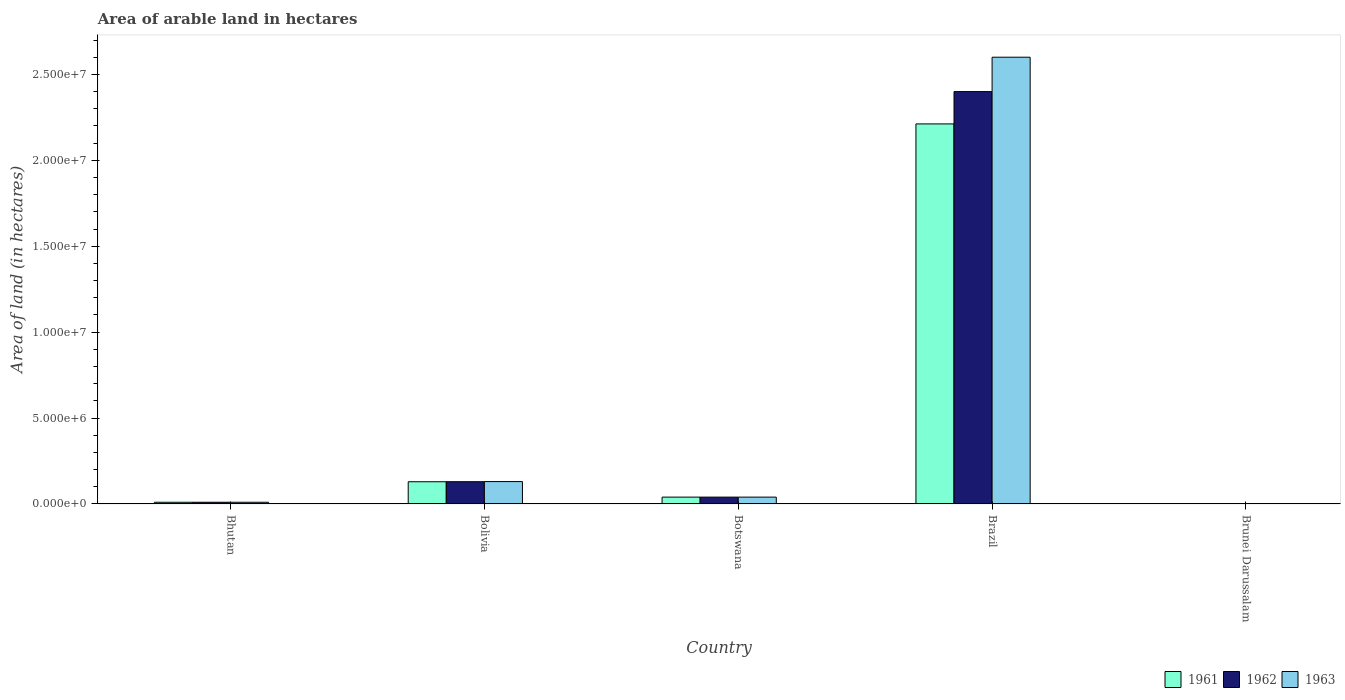How many groups of bars are there?
Your answer should be very brief. 5. Are the number of bars per tick equal to the number of legend labels?
Ensure brevity in your answer.  Yes. What is the label of the 3rd group of bars from the left?
Provide a succinct answer. Botswana. What is the total arable land in 1961 in Bolivia?
Keep it short and to the point. 1.29e+06. Across all countries, what is the maximum total arable land in 1962?
Ensure brevity in your answer.  2.40e+07. Across all countries, what is the minimum total arable land in 1963?
Provide a short and direct response. 4000. In which country was the total arable land in 1963 maximum?
Provide a succinct answer. Brazil. In which country was the total arable land in 1961 minimum?
Offer a terse response. Brunei Darussalam. What is the total total arable land in 1962 in the graph?
Provide a succinct answer. 2.58e+07. What is the difference between the total arable land in 1962 in Bolivia and that in Botswana?
Your response must be concise. 8.97e+05. What is the difference between the total arable land in 1962 in Bhutan and the total arable land in 1963 in Botswana?
Your answer should be very brief. -2.99e+05. What is the average total arable land in 1962 per country?
Offer a very short reply. 5.16e+06. What is the difference between the total arable land of/in 1961 and total arable land of/in 1963 in Bhutan?
Your answer should be compact. 0. In how many countries, is the total arable land in 1963 greater than 10000000 hectares?
Your response must be concise. 1. What is the difference between the highest and the second highest total arable land in 1963?
Your answer should be very brief. 2.56e+07. What is the difference between the highest and the lowest total arable land in 1962?
Offer a very short reply. 2.40e+07. In how many countries, is the total arable land in 1961 greater than the average total arable land in 1961 taken over all countries?
Keep it short and to the point. 1. What does the 3rd bar from the right in Bhutan represents?
Offer a terse response. 1961. Is it the case that in every country, the sum of the total arable land in 1961 and total arable land in 1963 is greater than the total arable land in 1962?
Ensure brevity in your answer.  Yes. How many bars are there?
Your answer should be very brief. 15. Are all the bars in the graph horizontal?
Provide a succinct answer. No. Are the values on the major ticks of Y-axis written in scientific E-notation?
Provide a short and direct response. Yes. Does the graph contain any zero values?
Keep it short and to the point. No. What is the title of the graph?
Ensure brevity in your answer.  Area of arable land in hectares. Does "1992" appear as one of the legend labels in the graph?
Your answer should be very brief. No. What is the label or title of the Y-axis?
Provide a succinct answer. Area of land (in hectares). What is the Area of land (in hectares) in 1961 in Bhutan?
Ensure brevity in your answer.  1.00e+05. What is the Area of land (in hectares) in 1962 in Bhutan?
Your answer should be very brief. 1.00e+05. What is the Area of land (in hectares) of 1963 in Bhutan?
Your response must be concise. 1.00e+05. What is the Area of land (in hectares) of 1961 in Bolivia?
Ensure brevity in your answer.  1.29e+06. What is the Area of land (in hectares) in 1962 in Bolivia?
Provide a succinct answer. 1.30e+06. What is the Area of land (in hectares) of 1963 in Bolivia?
Offer a very short reply. 1.30e+06. What is the Area of land (in hectares) in 1961 in Botswana?
Provide a short and direct response. 3.99e+05. What is the Area of land (in hectares) in 1962 in Botswana?
Make the answer very short. 3.99e+05. What is the Area of land (in hectares) of 1963 in Botswana?
Keep it short and to the point. 3.99e+05. What is the Area of land (in hectares) in 1961 in Brazil?
Your answer should be very brief. 2.21e+07. What is the Area of land (in hectares) in 1962 in Brazil?
Your response must be concise. 2.40e+07. What is the Area of land (in hectares) of 1963 in Brazil?
Your response must be concise. 2.60e+07. What is the Area of land (in hectares) in 1961 in Brunei Darussalam?
Your answer should be compact. 4000. What is the Area of land (in hectares) in 1962 in Brunei Darussalam?
Keep it short and to the point. 4000. What is the Area of land (in hectares) of 1963 in Brunei Darussalam?
Ensure brevity in your answer.  4000. Across all countries, what is the maximum Area of land (in hectares) in 1961?
Offer a terse response. 2.21e+07. Across all countries, what is the maximum Area of land (in hectares) in 1962?
Ensure brevity in your answer.  2.40e+07. Across all countries, what is the maximum Area of land (in hectares) in 1963?
Keep it short and to the point. 2.60e+07. Across all countries, what is the minimum Area of land (in hectares) in 1961?
Provide a short and direct response. 4000. Across all countries, what is the minimum Area of land (in hectares) of 1962?
Give a very brief answer. 4000. Across all countries, what is the minimum Area of land (in hectares) in 1963?
Ensure brevity in your answer.  4000. What is the total Area of land (in hectares) in 1961 in the graph?
Keep it short and to the point. 2.39e+07. What is the total Area of land (in hectares) in 1962 in the graph?
Your response must be concise. 2.58e+07. What is the total Area of land (in hectares) in 1963 in the graph?
Provide a short and direct response. 2.78e+07. What is the difference between the Area of land (in hectares) of 1961 in Bhutan and that in Bolivia?
Offer a very short reply. -1.19e+06. What is the difference between the Area of land (in hectares) in 1962 in Bhutan and that in Bolivia?
Your answer should be compact. -1.20e+06. What is the difference between the Area of land (in hectares) in 1963 in Bhutan and that in Bolivia?
Give a very brief answer. -1.20e+06. What is the difference between the Area of land (in hectares) in 1961 in Bhutan and that in Botswana?
Ensure brevity in your answer.  -2.99e+05. What is the difference between the Area of land (in hectares) of 1962 in Bhutan and that in Botswana?
Your response must be concise. -2.99e+05. What is the difference between the Area of land (in hectares) in 1963 in Bhutan and that in Botswana?
Provide a short and direct response. -2.99e+05. What is the difference between the Area of land (in hectares) in 1961 in Bhutan and that in Brazil?
Keep it short and to the point. -2.20e+07. What is the difference between the Area of land (in hectares) in 1962 in Bhutan and that in Brazil?
Make the answer very short. -2.39e+07. What is the difference between the Area of land (in hectares) in 1963 in Bhutan and that in Brazil?
Provide a short and direct response. -2.59e+07. What is the difference between the Area of land (in hectares) in 1961 in Bhutan and that in Brunei Darussalam?
Provide a succinct answer. 9.60e+04. What is the difference between the Area of land (in hectares) of 1962 in Bhutan and that in Brunei Darussalam?
Your answer should be compact. 9.60e+04. What is the difference between the Area of land (in hectares) of 1963 in Bhutan and that in Brunei Darussalam?
Offer a terse response. 9.60e+04. What is the difference between the Area of land (in hectares) in 1961 in Bolivia and that in Botswana?
Offer a terse response. 8.95e+05. What is the difference between the Area of land (in hectares) of 1962 in Bolivia and that in Botswana?
Provide a succinct answer. 8.97e+05. What is the difference between the Area of land (in hectares) of 1963 in Bolivia and that in Botswana?
Your answer should be compact. 9.05e+05. What is the difference between the Area of land (in hectares) in 1961 in Bolivia and that in Brazil?
Offer a terse response. -2.08e+07. What is the difference between the Area of land (in hectares) in 1962 in Bolivia and that in Brazil?
Ensure brevity in your answer.  -2.27e+07. What is the difference between the Area of land (in hectares) in 1963 in Bolivia and that in Brazil?
Your answer should be compact. -2.47e+07. What is the difference between the Area of land (in hectares) in 1961 in Bolivia and that in Brunei Darussalam?
Provide a succinct answer. 1.29e+06. What is the difference between the Area of land (in hectares) in 1962 in Bolivia and that in Brunei Darussalam?
Keep it short and to the point. 1.29e+06. What is the difference between the Area of land (in hectares) of 1963 in Bolivia and that in Brunei Darussalam?
Your response must be concise. 1.30e+06. What is the difference between the Area of land (in hectares) in 1961 in Botswana and that in Brazil?
Your answer should be very brief. -2.17e+07. What is the difference between the Area of land (in hectares) of 1962 in Botswana and that in Brazil?
Offer a very short reply. -2.36e+07. What is the difference between the Area of land (in hectares) of 1963 in Botswana and that in Brazil?
Keep it short and to the point. -2.56e+07. What is the difference between the Area of land (in hectares) in 1961 in Botswana and that in Brunei Darussalam?
Offer a terse response. 3.95e+05. What is the difference between the Area of land (in hectares) of 1962 in Botswana and that in Brunei Darussalam?
Offer a very short reply. 3.95e+05. What is the difference between the Area of land (in hectares) in 1963 in Botswana and that in Brunei Darussalam?
Provide a succinct answer. 3.95e+05. What is the difference between the Area of land (in hectares) of 1961 in Brazil and that in Brunei Darussalam?
Your response must be concise. 2.21e+07. What is the difference between the Area of land (in hectares) in 1962 in Brazil and that in Brunei Darussalam?
Your answer should be very brief. 2.40e+07. What is the difference between the Area of land (in hectares) of 1963 in Brazil and that in Brunei Darussalam?
Offer a very short reply. 2.60e+07. What is the difference between the Area of land (in hectares) in 1961 in Bhutan and the Area of land (in hectares) in 1962 in Bolivia?
Provide a succinct answer. -1.20e+06. What is the difference between the Area of land (in hectares) of 1961 in Bhutan and the Area of land (in hectares) of 1963 in Bolivia?
Give a very brief answer. -1.20e+06. What is the difference between the Area of land (in hectares) in 1962 in Bhutan and the Area of land (in hectares) in 1963 in Bolivia?
Your answer should be compact. -1.20e+06. What is the difference between the Area of land (in hectares) in 1961 in Bhutan and the Area of land (in hectares) in 1962 in Botswana?
Provide a succinct answer. -2.99e+05. What is the difference between the Area of land (in hectares) of 1961 in Bhutan and the Area of land (in hectares) of 1963 in Botswana?
Give a very brief answer. -2.99e+05. What is the difference between the Area of land (in hectares) of 1962 in Bhutan and the Area of land (in hectares) of 1963 in Botswana?
Your answer should be very brief. -2.99e+05. What is the difference between the Area of land (in hectares) of 1961 in Bhutan and the Area of land (in hectares) of 1962 in Brazil?
Provide a succinct answer. -2.39e+07. What is the difference between the Area of land (in hectares) in 1961 in Bhutan and the Area of land (in hectares) in 1963 in Brazil?
Ensure brevity in your answer.  -2.59e+07. What is the difference between the Area of land (in hectares) of 1962 in Bhutan and the Area of land (in hectares) of 1963 in Brazil?
Your answer should be very brief. -2.59e+07. What is the difference between the Area of land (in hectares) of 1961 in Bhutan and the Area of land (in hectares) of 1962 in Brunei Darussalam?
Your response must be concise. 9.60e+04. What is the difference between the Area of land (in hectares) of 1961 in Bhutan and the Area of land (in hectares) of 1963 in Brunei Darussalam?
Give a very brief answer. 9.60e+04. What is the difference between the Area of land (in hectares) in 1962 in Bhutan and the Area of land (in hectares) in 1963 in Brunei Darussalam?
Make the answer very short. 9.60e+04. What is the difference between the Area of land (in hectares) in 1961 in Bolivia and the Area of land (in hectares) in 1962 in Botswana?
Ensure brevity in your answer.  8.95e+05. What is the difference between the Area of land (in hectares) of 1961 in Bolivia and the Area of land (in hectares) of 1963 in Botswana?
Provide a short and direct response. 8.95e+05. What is the difference between the Area of land (in hectares) of 1962 in Bolivia and the Area of land (in hectares) of 1963 in Botswana?
Provide a succinct answer. 8.97e+05. What is the difference between the Area of land (in hectares) of 1961 in Bolivia and the Area of land (in hectares) of 1962 in Brazil?
Offer a very short reply. -2.27e+07. What is the difference between the Area of land (in hectares) of 1961 in Bolivia and the Area of land (in hectares) of 1963 in Brazil?
Provide a succinct answer. -2.47e+07. What is the difference between the Area of land (in hectares) of 1962 in Bolivia and the Area of land (in hectares) of 1963 in Brazil?
Keep it short and to the point. -2.47e+07. What is the difference between the Area of land (in hectares) in 1961 in Bolivia and the Area of land (in hectares) in 1962 in Brunei Darussalam?
Your response must be concise. 1.29e+06. What is the difference between the Area of land (in hectares) of 1961 in Bolivia and the Area of land (in hectares) of 1963 in Brunei Darussalam?
Your response must be concise. 1.29e+06. What is the difference between the Area of land (in hectares) of 1962 in Bolivia and the Area of land (in hectares) of 1963 in Brunei Darussalam?
Give a very brief answer. 1.29e+06. What is the difference between the Area of land (in hectares) in 1961 in Botswana and the Area of land (in hectares) in 1962 in Brazil?
Your answer should be very brief. -2.36e+07. What is the difference between the Area of land (in hectares) in 1961 in Botswana and the Area of land (in hectares) in 1963 in Brazil?
Make the answer very short. -2.56e+07. What is the difference between the Area of land (in hectares) of 1962 in Botswana and the Area of land (in hectares) of 1963 in Brazil?
Your answer should be very brief. -2.56e+07. What is the difference between the Area of land (in hectares) in 1961 in Botswana and the Area of land (in hectares) in 1962 in Brunei Darussalam?
Provide a succinct answer. 3.95e+05. What is the difference between the Area of land (in hectares) in 1961 in Botswana and the Area of land (in hectares) in 1963 in Brunei Darussalam?
Your answer should be very brief. 3.95e+05. What is the difference between the Area of land (in hectares) of 1962 in Botswana and the Area of land (in hectares) of 1963 in Brunei Darussalam?
Make the answer very short. 3.95e+05. What is the difference between the Area of land (in hectares) of 1961 in Brazil and the Area of land (in hectares) of 1962 in Brunei Darussalam?
Offer a very short reply. 2.21e+07. What is the difference between the Area of land (in hectares) of 1961 in Brazil and the Area of land (in hectares) of 1963 in Brunei Darussalam?
Offer a terse response. 2.21e+07. What is the difference between the Area of land (in hectares) in 1962 in Brazil and the Area of land (in hectares) in 1963 in Brunei Darussalam?
Make the answer very short. 2.40e+07. What is the average Area of land (in hectares) in 1961 per country?
Provide a succinct answer. 4.78e+06. What is the average Area of land (in hectares) in 1962 per country?
Provide a short and direct response. 5.16e+06. What is the average Area of land (in hectares) in 1963 per country?
Your response must be concise. 5.56e+06. What is the difference between the Area of land (in hectares) in 1961 and Area of land (in hectares) in 1962 in Bhutan?
Your answer should be compact. 0. What is the difference between the Area of land (in hectares) of 1961 and Area of land (in hectares) of 1963 in Bhutan?
Keep it short and to the point. 0. What is the difference between the Area of land (in hectares) of 1961 and Area of land (in hectares) of 1962 in Bolivia?
Provide a succinct answer. -2000. What is the difference between the Area of land (in hectares) of 1961 and Area of land (in hectares) of 1963 in Bolivia?
Provide a succinct answer. -10000. What is the difference between the Area of land (in hectares) of 1962 and Area of land (in hectares) of 1963 in Bolivia?
Your answer should be compact. -8000. What is the difference between the Area of land (in hectares) of 1961 and Area of land (in hectares) of 1962 in Brazil?
Ensure brevity in your answer.  -1.88e+06. What is the difference between the Area of land (in hectares) of 1961 and Area of land (in hectares) of 1963 in Brazil?
Make the answer very short. -3.88e+06. What is the difference between the Area of land (in hectares) of 1962 and Area of land (in hectares) of 1963 in Brazil?
Provide a short and direct response. -2.00e+06. What is the difference between the Area of land (in hectares) in 1961 and Area of land (in hectares) in 1963 in Brunei Darussalam?
Your answer should be very brief. 0. What is the difference between the Area of land (in hectares) in 1962 and Area of land (in hectares) in 1963 in Brunei Darussalam?
Ensure brevity in your answer.  0. What is the ratio of the Area of land (in hectares) of 1961 in Bhutan to that in Bolivia?
Offer a very short reply. 0.08. What is the ratio of the Area of land (in hectares) in 1962 in Bhutan to that in Bolivia?
Your answer should be very brief. 0.08. What is the ratio of the Area of land (in hectares) of 1963 in Bhutan to that in Bolivia?
Your response must be concise. 0.08. What is the ratio of the Area of land (in hectares) of 1961 in Bhutan to that in Botswana?
Keep it short and to the point. 0.25. What is the ratio of the Area of land (in hectares) of 1962 in Bhutan to that in Botswana?
Make the answer very short. 0.25. What is the ratio of the Area of land (in hectares) of 1963 in Bhutan to that in Botswana?
Provide a short and direct response. 0.25. What is the ratio of the Area of land (in hectares) in 1961 in Bhutan to that in Brazil?
Provide a short and direct response. 0. What is the ratio of the Area of land (in hectares) of 1962 in Bhutan to that in Brazil?
Ensure brevity in your answer.  0. What is the ratio of the Area of land (in hectares) of 1963 in Bhutan to that in Brazil?
Offer a very short reply. 0. What is the ratio of the Area of land (in hectares) of 1962 in Bhutan to that in Brunei Darussalam?
Keep it short and to the point. 25. What is the ratio of the Area of land (in hectares) in 1963 in Bhutan to that in Brunei Darussalam?
Offer a terse response. 25. What is the ratio of the Area of land (in hectares) in 1961 in Bolivia to that in Botswana?
Make the answer very short. 3.24. What is the ratio of the Area of land (in hectares) of 1962 in Bolivia to that in Botswana?
Your answer should be very brief. 3.25. What is the ratio of the Area of land (in hectares) of 1963 in Bolivia to that in Botswana?
Make the answer very short. 3.27. What is the ratio of the Area of land (in hectares) of 1961 in Bolivia to that in Brazil?
Give a very brief answer. 0.06. What is the ratio of the Area of land (in hectares) of 1962 in Bolivia to that in Brazil?
Make the answer very short. 0.05. What is the ratio of the Area of land (in hectares) of 1963 in Bolivia to that in Brazil?
Keep it short and to the point. 0.05. What is the ratio of the Area of land (in hectares) of 1961 in Bolivia to that in Brunei Darussalam?
Give a very brief answer. 323.5. What is the ratio of the Area of land (in hectares) in 1962 in Bolivia to that in Brunei Darussalam?
Your answer should be compact. 324. What is the ratio of the Area of land (in hectares) of 1963 in Bolivia to that in Brunei Darussalam?
Offer a very short reply. 326. What is the ratio of the Area of land (in hectares) in 1961 in Botswana to that in Brazil?
Ensure brevity in your answer.  0.02. What is the ratio of the Area of land (in hectares) of 1962 in Botswana to that in Brazil?
Offer a very short reply. 0.02. What is the ratio of the Area of land (in hectares) in 1963 in Botswana to that in Brazil?
Provide a short and direct response. 0.02. What is the ratio of the Area of land (in hectares) of 1961 in Botswana to that in Brunei Darussalam?
Your answer should be very brief. 99.75. What is the ratio of the Area of land (in hectares) of 1962 in Botswana to that in Brunei Darussalam?
Ensure brevity in your answer.  99.75. What is the ratio of the Area of land (in hectares) of 1963 in Botswana to that in Brunei Darussalam?
Your answer should be compact. 99.75. What is the ratio of the Area of land (in hectares) in 1961 in Brazil to that in Brunei Darussalam?
Make the answer very short. 5529.5. What is the ratio of the Area of land (in hectares) of 1962 in Brazil to that in Brunei Darussalam?
Keep it short and to the point. 6000. What is the ratio of the Area of land (in hectares) of 1963 in Brazil to that in Brunei Darussalam?
Offer a terse response. 6500. What is the difference between the highest and the second highest Area of land (in hectares) of 1961?
Make the answer very short. 2.08e+07. What is the difference between the highest and the second highest Area of land (in hectares) of 1962?
Offer a terse response. 2.27e+07. What is the difference between the highest and the second highest Area of land (in hectares) in 1963?
Provide a short and direct response. 2.47e+07. What is the difference between the highest and the lowest Area of land (in hectares) in 1961?
Your response must be concise. 2.21e+07. What is the difference between the highest and the lowest Area of land (in hectares) of 1962?
Your answer should be compact. 2.40e+07. What is the difference between the highest and the lowest Area of land (in hectares) of 1963?
Keep it short and to the point. 2.60e+07. 